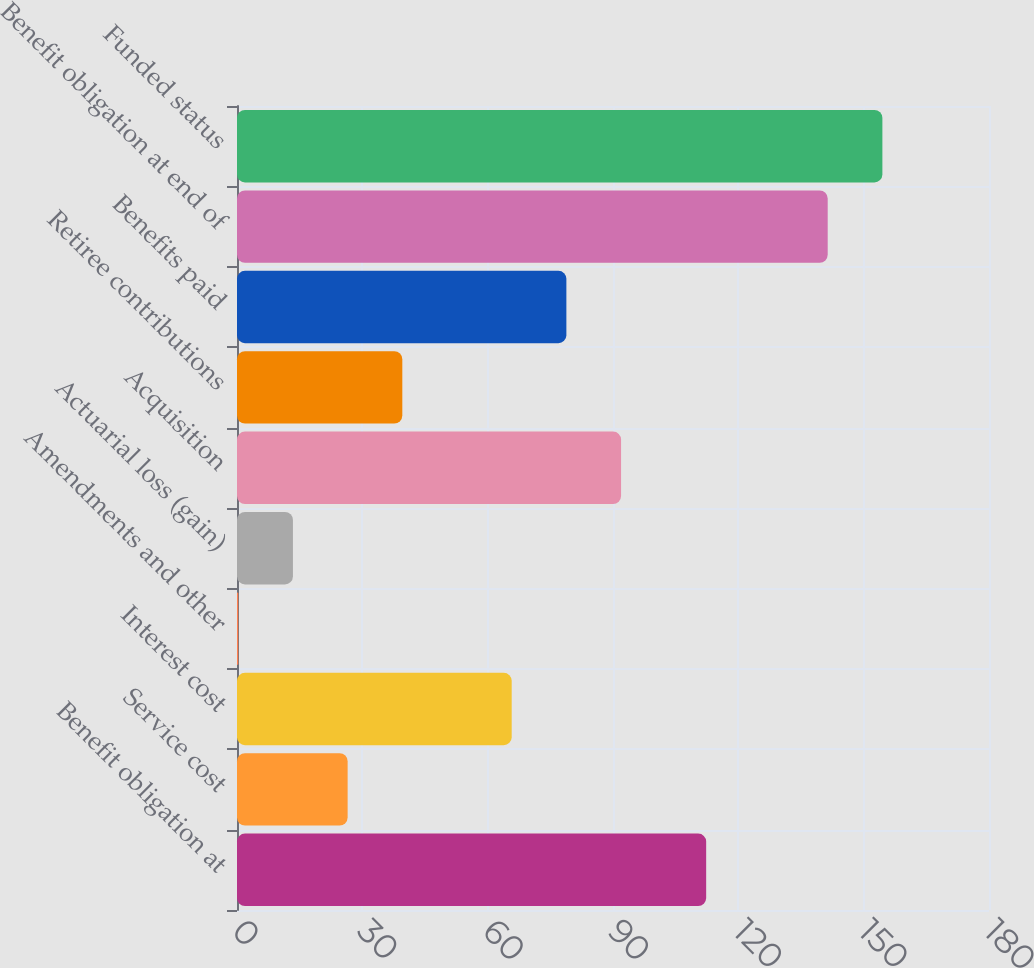Convert chart. <chart><loc_0><loc_0><loc_500><loc_500><bar_chart><fcel>Benefit obligation at<fcel>Service cost<fcel>Interest cost<fcel>Amendments and other<fcel>Actuarial loss (gain)<fcel>Acquisition<fcel>Retiree contributions<fcel>Benefits paid<fcel>Benefit obligation at end of<fcel>Funded status<nl><fcel>112.3<fcel>26.48<fcel>65.75<fcel>0.3<fcel>13.39<fcel>91.93<fcel>39.57<fcel>78.84<fcel>141.39<fcel>154.48<nl></chart> 